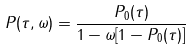<formula> <loc_0><loc_0><loc_500><loc_500>P ( \tau , \omega ) = \frac { P _ { 0 } ( \tau ) } { 1 - \omega [ 1 - P _ { 0 } ( \tau ) ] }</formula> 